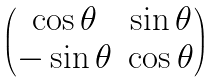Convert formula to latex. <formula><loc_0><loc_0><loc_500><loc_500>\begin{pmatrix} \cos { \theta } & \sin { \theta } \\ - \sin { \theta } & \cos { \theta } \end{pmatrix}</formula> 